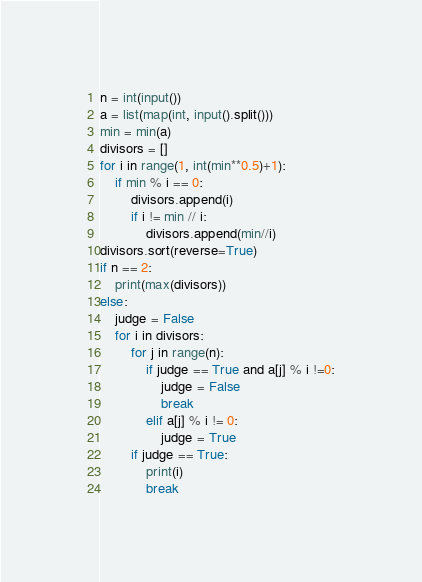Convert code to text. <code><loc_0><loc_0><loc_500><loc_500><_Python_>n = int(input())
a = list(map(int, input().split()))
min = min(a)
divisors = []
for i in range(1, int(min**0.5)+1):
    if min % i == 0:
        divisors.append(i)
        if i != min // i:
            divisors.append(min//i)
divisors.sort(reverse=True)
if n == 2:
    print(max(divisors))
else:
    judge = False
    for i in divisors:
        for j in range(n):
            if judge == True and a[j] % i !=0:
                judge = False
                break
            elif a[j] % i != 0:
                judge = True
        if judge == True:
            print(i)
            break</code> 